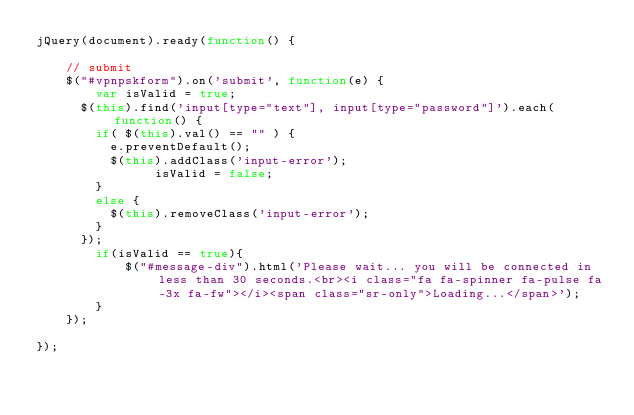<code> <loc_0><loc_0><loc_500><loc_500><_JavaScript_>jQuery(document).ready(function() {
    
    // submit
    $("#vpnpskform").on('submit', function(e) {
        var isValid = true;
    	$(this).find('input[type="text"], input[type="password"]').each(function() {
    		if( $(this).val() == "" ) {
    			e.preventDefault();
    			$(this).addClass('input-error');
                isValid = false;
    		}
    		else {
    			$(this).removeClass('input-error');
    		}
    	});
        if(isValid == true){
            $("#message-div").html('Please wait... you will be connected in less than 30 seconds.<br><i class="fa fa-spinner fa-pulse fa-3x fa-fw"></i><span class="sr-only">Loading...</span>');
        }
    });

});</code> 